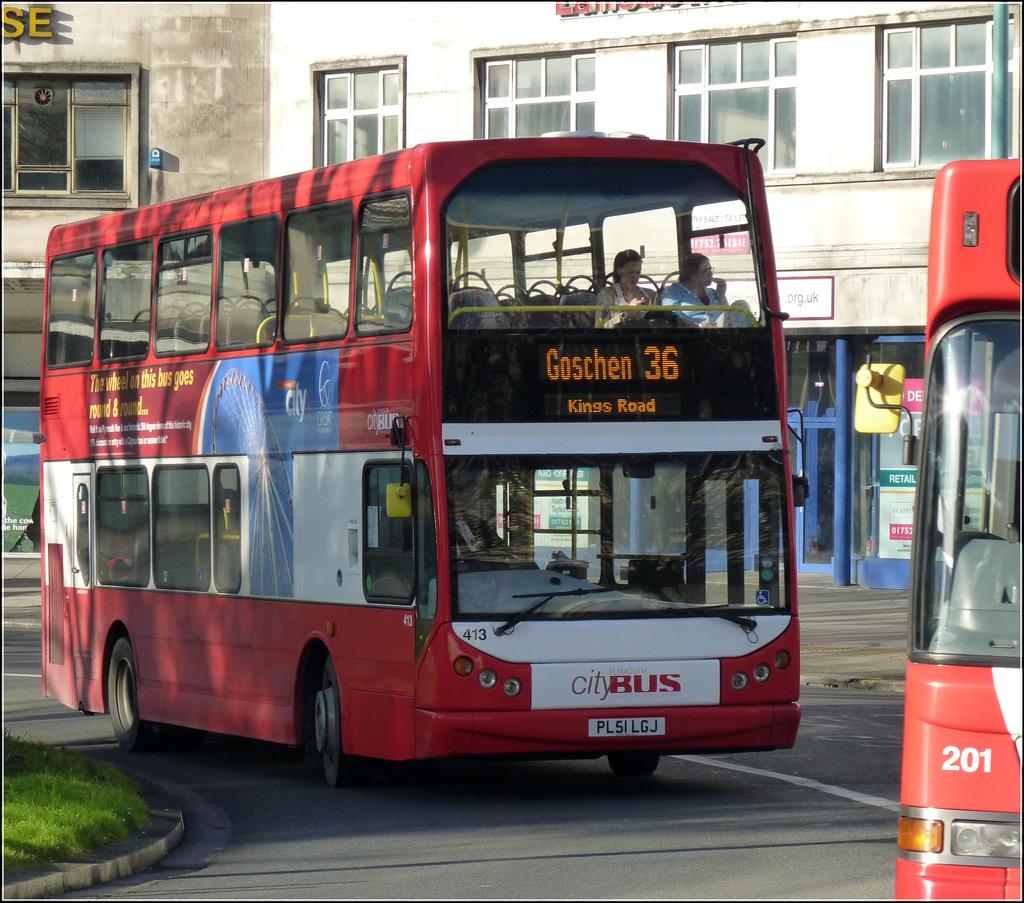What number is this bus?
Offer a terse response. 36. Where is the bus headed?
Offer a terse response. Goschen. 